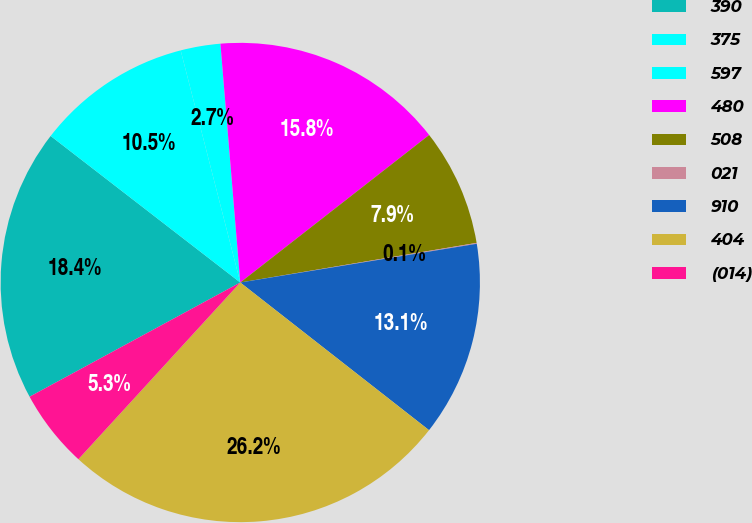Convert chart. <chart><loc_0><loc_0><loc_500><loc_500><pie_chart><fcel>390<fcel>375<fcel>597<fcel>480<fcel>508<fcel>021<fcel>910<fcel>404<fcel>(014)<nl><fcel>18.38%<fcel>10.53%<fcel>2.68%<fcel>15.77%<fcel>7.91%<fcel>0.06%<fcel>13.15%<fcel>26.24%<fcel>5.29%<nl></chart> 